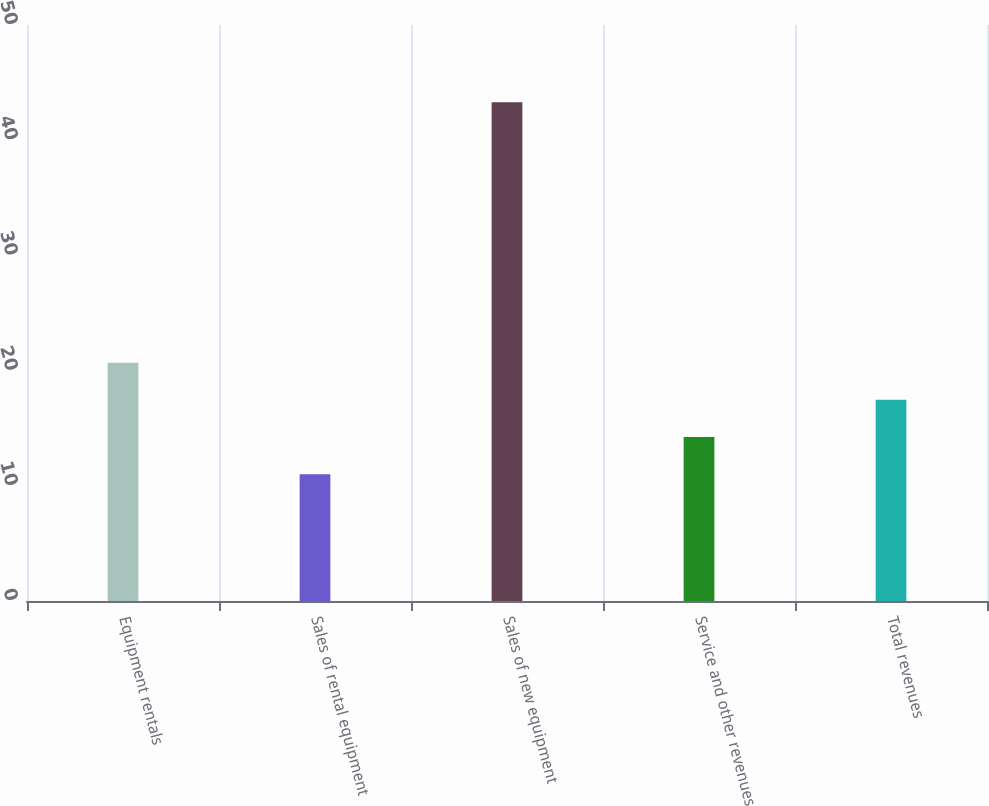<chart> <loc_0><loc_0><loc_500><loc_500><bar_chart><fcel>Equipment rentals<fcel>Sales of rental equipment<fcel>Sales of new equipment<fcel>Service and other revenues<fcel>Total revenues<nl><fcel>20.69<fcel>11<fcel>43.3<fcel>14.23<fcel>17.46<nl></chart> 